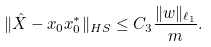Convert formula to latex. <formula><loc_0><loc_0><loc_500><loc_500>\| \hat { X } - x _ { 0 } x ^ { * } _ { 0 } \| _ { H S } \leq C _ { 3 } \frac { \| w \| _ { \ell _ { 1 } } } { m } .</formula> 